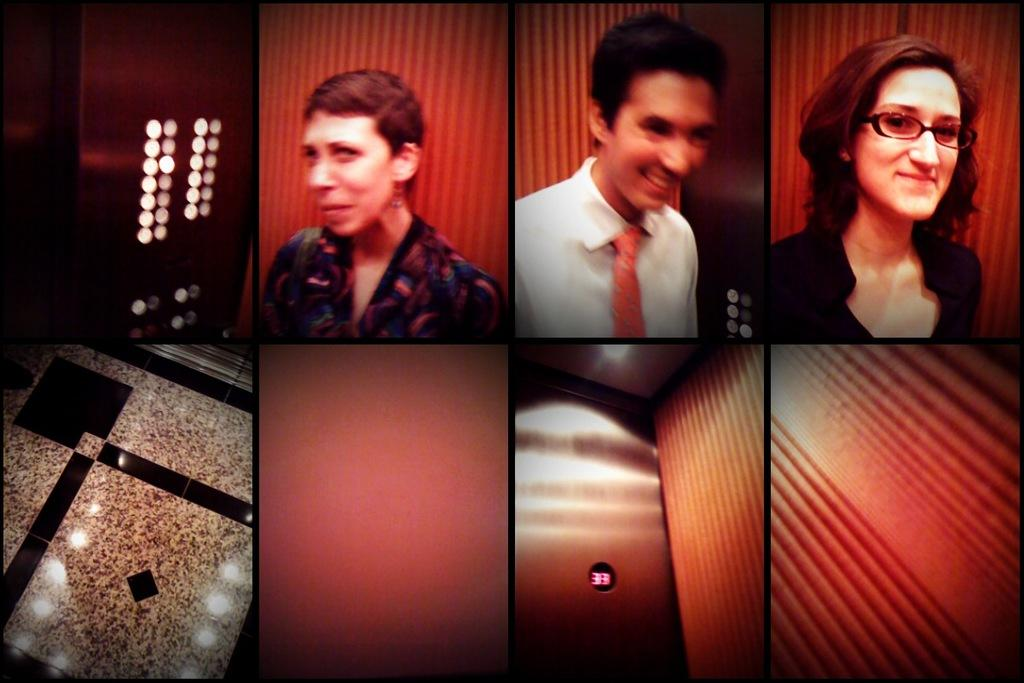What type of image is being described? The image is a collage. What can be found inside the collage? There is a lift in the image. What features are present in the lift? There are buttons, a floor, and a door in the lift. Who is inside the lift? There are people standing in the lift. How are the people in the lift feeling? The people in the lift are smiling. What type of substance is being spilled by the friend in the image? There is no friend or substance being spilled in the image; it features a lift with people inside. Is there a gun visible in the image? No, there is no gun present in the image. 